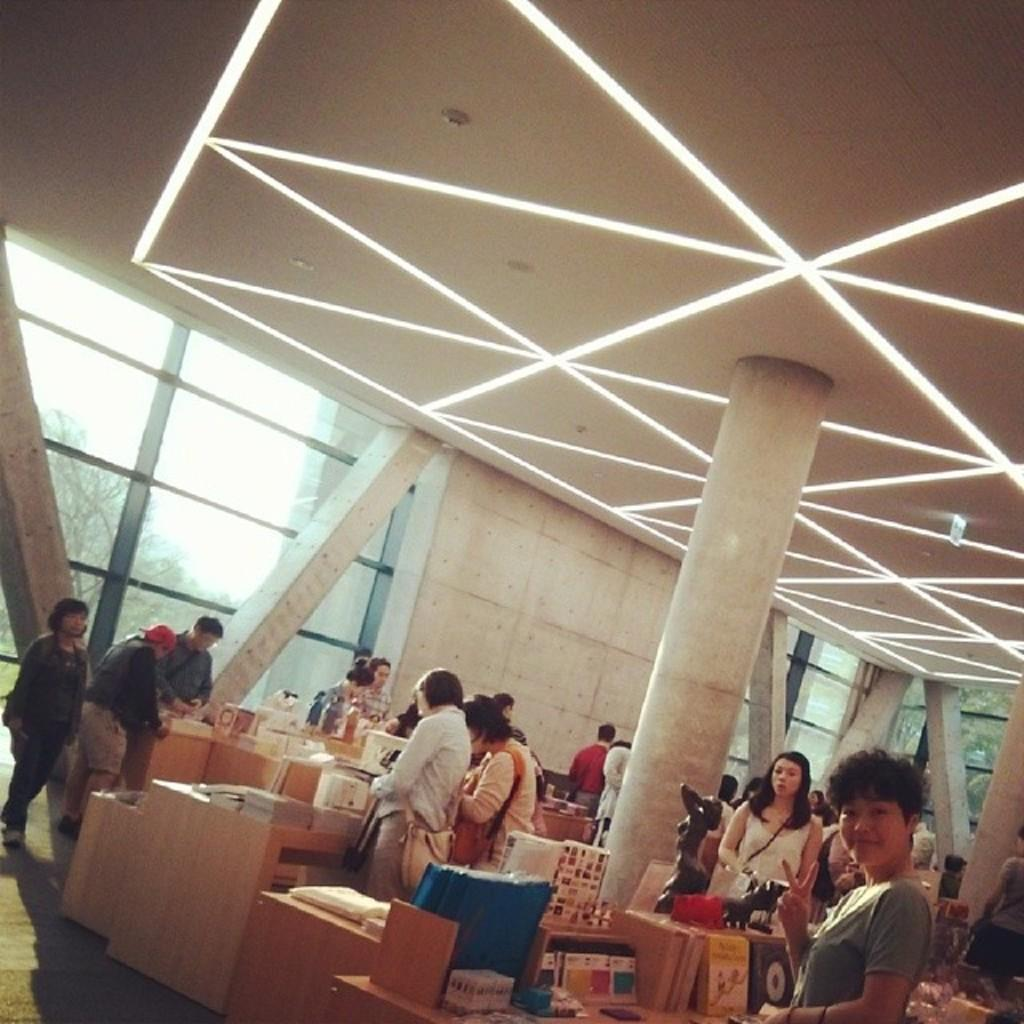What is happening in the image? There are people standing in the image. What else can be seen in the image besides the people? There is furniture in the image. What is visible in the background of the image? There is a window in the background of the image, and through it, the sky and trees are visible. What type of bell can be heard ringing in the image? There is no bell present in the image, and therefore no sound can be heard. 